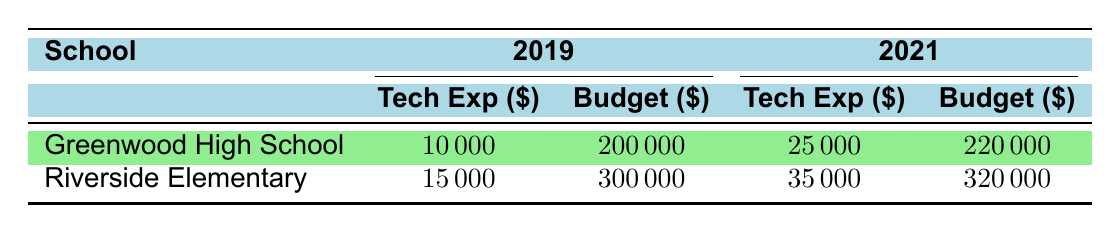What was the technology expenditure for Greenwood High School in 2019? The table lists Greenwood High School under the 2019 column. The technology expenditure for that year is $10,000.
Answer: $10,000 How much did Riverside Elementary spend on technology in 2021? By looking at the 2021 column for Riverside Elementary, the technology expenditure is recorded as $35,000.
Answer: $35,000 What is the difference in technology expenditure between Greenwood High School in 2019 and 2021? Greenwood High School's technology expenditure in 2019 is $10,000, and in 2021 it is $25,000. The difference is $25,000 - $10,000 = $15,000.
Answer: $15,000 Did Riverside Elementary increase its overall budget from 2019 to 2021? Riverside Elementary's overall budget for 2019 is $300,000, and for 2021, it is $320,000. Since $320,000 is greater than $300,000, it did increase.
Answer: Yes What is the total technology expenditure for both schools combined in 2021? Adding the technology expenditures for both schools in 2021: Greenwood High School is $25,000 and Riverside Elementary is $35,000. The total is $25,000 + $35,000 = $60,000.
Answer: $60,000 Did the technology expenditure for Greenwood High School increase by more than $10,000 from 2019 to 2021? The expenditure in 2019 was $10,000, and in 2021 it was $25,000. The increase is $25,000 - $10,000 = $15,000, which is greater than $10,000.
Answer: Yes What is the average technology expenditure for Riverside Elementary over the two years? Riverside Elementary's expenditures are $15,000 in 2019 and $35,000 in 2021. The average is calculated as ($15,000 + $35,000) / 2 = $25,000.
Answer: $25,000 Is the technology expenditure as a percentage of the overall budget higher for Greenwood High School in 2021 than in 2019? For 2019, Greenwood High School's technology expenditure as a percentage of the budget is $10,000 / $200,000 = 5%. For 2021, it is $25,000 / $220,000 = 11.36%. Since 11.36% is greater than 5%, it is higher.
Answer: Yes 